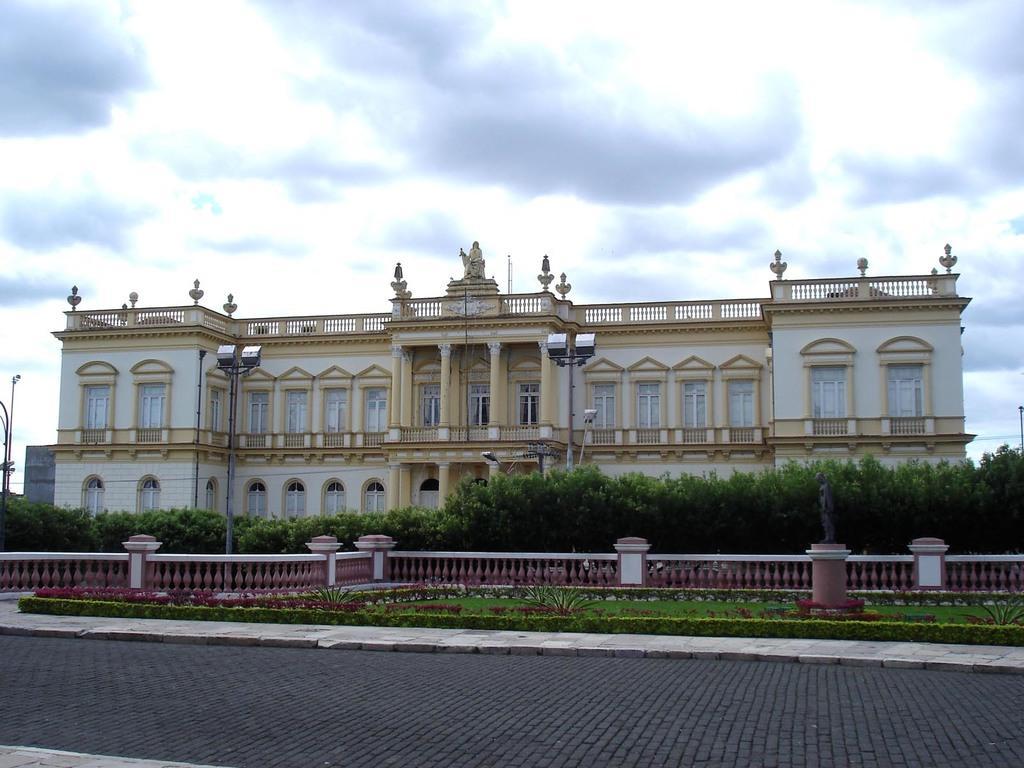Could you give a brief overview of what you see in this image? At the center of the image there is a building, in front of the building there are trees, plants, streetlights, fencing, in front of the fencing there is a grass with plants and there is a road. In the background there is a sky. 